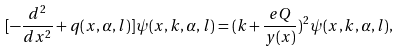Convert formula to latex. <formula><loc_0><loc_0><loc_500><loc_500>[ - \frac { d ^ { 2 } } { d x ^ { 2 } } + q ( x , \alpha , l ) ] \psi ( x , k , \alpha , l ) = ( k + \frac { e Q } { y ( x ) } ) ^ { 2 } \psi ( x , k , \alpha , l ) ,</formula> 